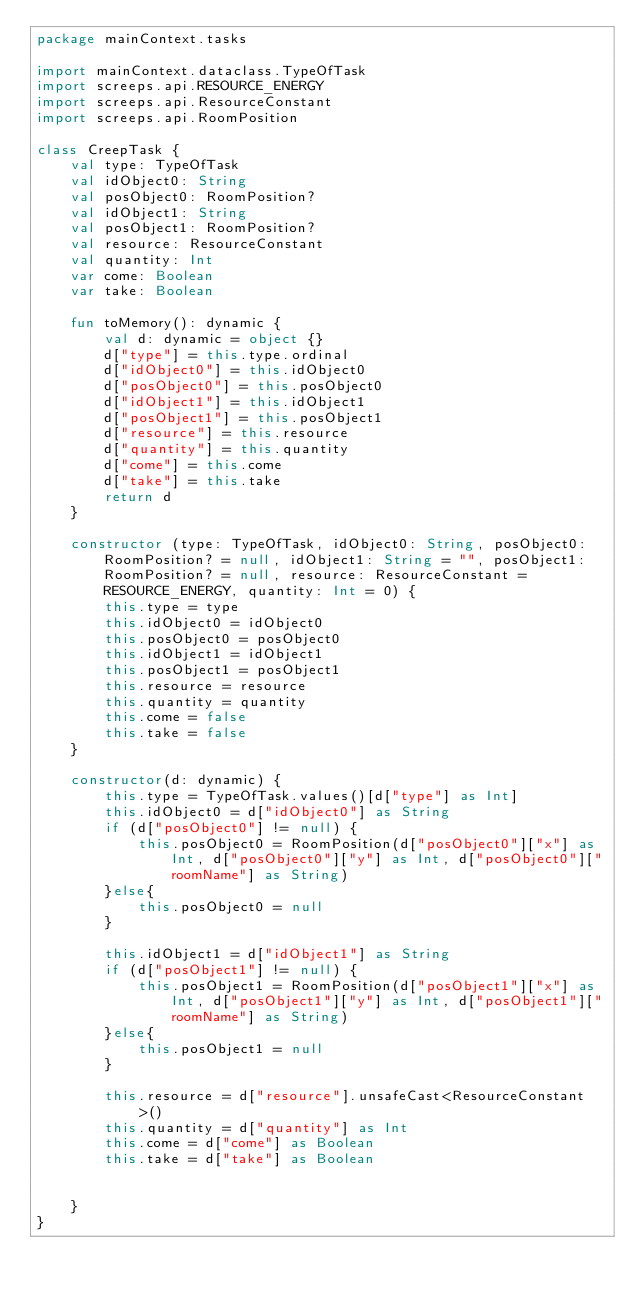Convert code to text. <code><loc_0><loc_0><loc_500><loc_500><_Kotlin_>package mainContext.tasks

import mainContext.dataclass.TypeOfTask
import screeps.api.RESOURCE_ENERGY
import screeps.api.ResourceConstant
import screeps.api.RoomPosition

class CreepTask {
    val type: TypeOfTask
    val idObject0: String
    val posObject0: RoomPosition?
    val idObject1: String
    val posObject1: RoomPosition?
    val resource: ResourceConstant
    val quantity: Int
    var come: Boolean
    var take: Boolean

    fun toMemory(): dynamic {
        val d: dynamic = object {}
        d["type"] = this.type.ordinal
        d["idObject0"] = this.idObject0
        d["posObject0"] = this.posObject0
        d["idObject1"] = this.idObject1
        d["posObject1"] = this.posObject1
        d["resource"] = this.resource
        d["quantity"] = this.quantity
        d["come"] = this.come
        d["take"] = this.take
        return d
    }

    constructor (type: TypeOfTask, idObject0: String, posObject0: RoomPosition? = null, idObject1: String = "", posObject1: RoomPosition? = null, resource: ResourceConstant = RESOURCE_ENERGY, quantity: Int = 0) {
        this.type = type
        this.idObject0 = idObject0
        this.posObject0 = posObject0
        this.idObject1 = idObject1
        this.posObject1 = posObject1
        this.resource = resource
        this.quantity = quantity
        this.come = false
        this.take = false
    }

    constructor(d: dynamic) {
        this.type = TypeOfTask.values()[d["type"] as Int]
        this.idObject0 = d["idObject0"] as String
        if (d["posObject0"] != null) {
            this.posObject0 = RoomPosition(d["posObject0"]["x"] as Int, d["posObject0"]["y"] as Int, d["posObject0"]["roomName"] as String)
        }else{
            this.posObject0 = null
        }

        this.idObject1 = d["idObject1"] as String
        if (d["posObject1"] != null) {
            this.posObject1 = RoomPosition(d["posObject1"]["x"] as Int, d["posObject1"]["y"] as Int, d["posObject1"]["roomName"] as String)
        }else{
            this.posObject1 = null
        }

        this.resource = d["resource"].unsafeCast<ResourceConstant>()
        this.quantity = d["quantity"] as Int
        this.come = d["come"] as Boolean
        this.take = d["take"] as Boolean


    }
}</code> 